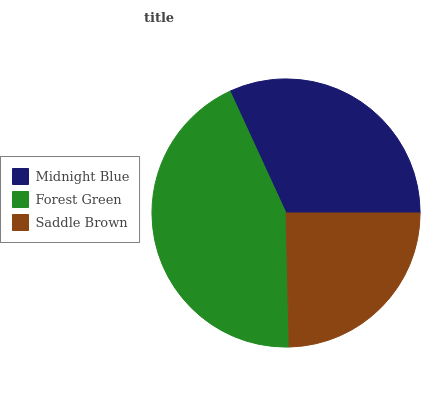Is Saddle Brown the minimum?
Answer yes or no. Yes. Is Forest Green the maximum?
Answer yes or no. Yes. Is Forest Green the minimum?
Answer yes or no. No. Is Saddle Brown the maximum?
Answer yes or no. No. Is Forest Green greater than Saddle Brown?
Answer yes or no. Yes. Is Saddle Brown less than Forest Green?
Answer yes or no. Yes. Is Saddle Brown greater than Forest Green?
Answer yes or no. No. Is Forest Green less than Saddle Brown?
Answer yes or no. No. Is Midnight Blue the high median?
Answer yes or no. Yes. Is Midnight Blue the low median?
Answer yes or no. Yes. Is Saddle Brown the high median?
Answer yes or no. No. Is Saddle Brown the low median?
Answer yes or no. No. 